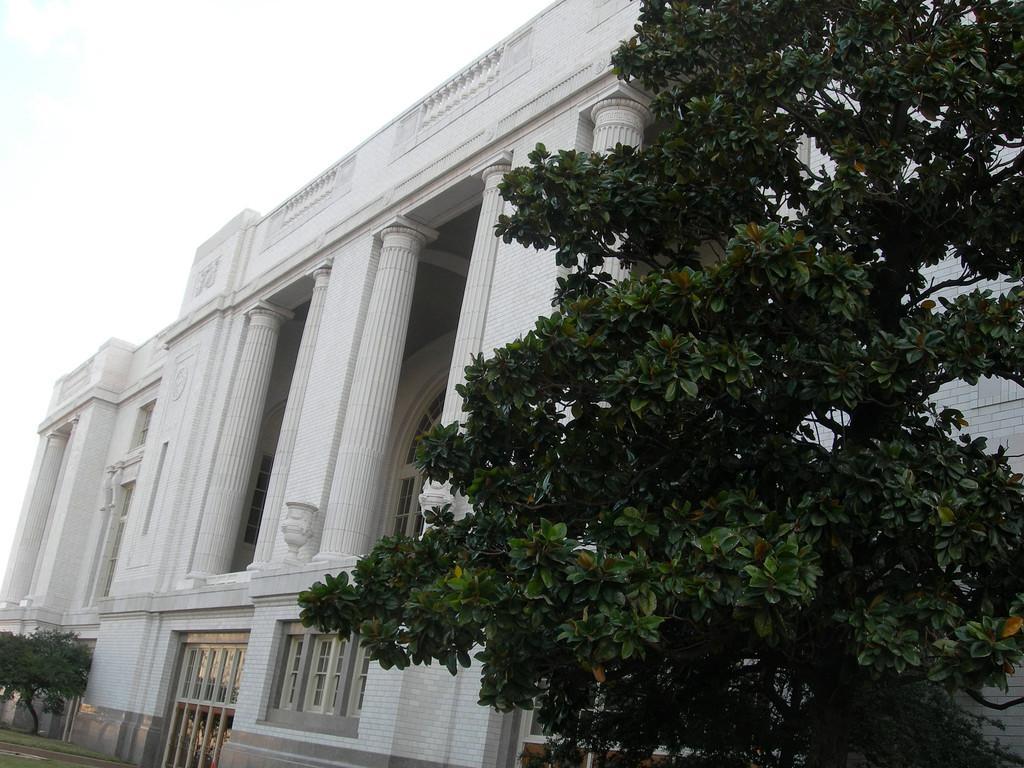Describe this image in one or two sentences. In this picture on the right side there is a tree and near this tree there is a big tree and the background is the sky. 